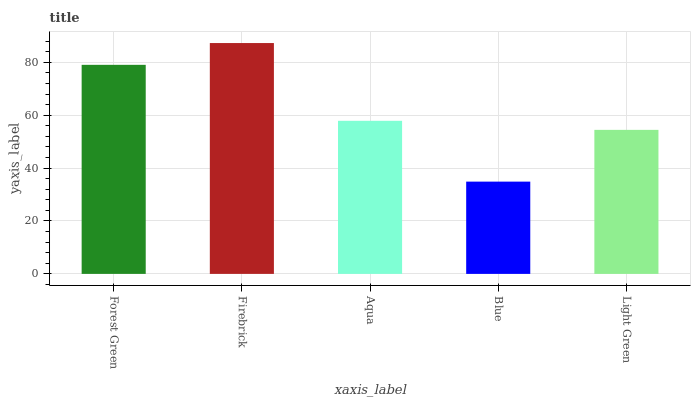Is Blue the minimum?
Answer yes or no. Yes. Is Firebrick the maximum?
Answer yes or no. Yes. Is Aqua the minimum?
Answer yes or no. No. Is Aqua the maximum?
Answer yes or no. No. Is Firebrick greater than Aqua?
Answer yes or no. Yes. Is Aqua less than Firebrick?
Answer yes or no. Yes. Is Aqua greater than Firebrick?
Answer yes or no. No. Is Firebrick less than Aqua?
Answer yes or no. No. Is Aqua the high median?
Answer yes or no. Yes. Is Aqua the low median?
Answer yes or no. Yes. Is Blue the high median?
Answer yes or no. No. Is Light Green the low median?
Answer yes or no. No. 